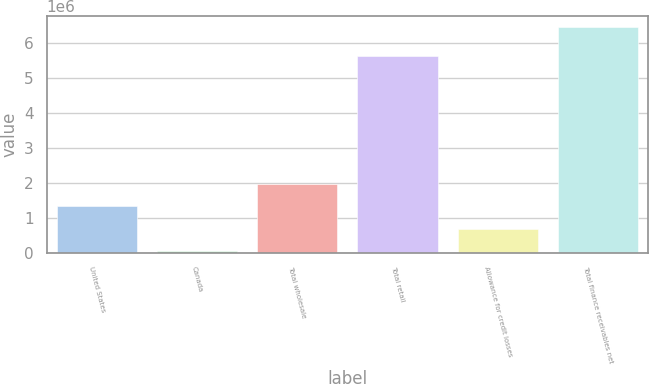Convert chart to OTSL. <chart><loc_0><loc_0><loc_500><loc_500><bar_chart><fcel>United States<fcel>Canada<fcel>Total wholesale<fcel>Total retail<fcel>Allowance for credit losses<fcel>Total finance receivables net<nl><fcel>1.32573e+06<fcel>48941<fcel>1.96412e+06<fcel>5.60792e+06<fcel>687335<fcel>6.43288e+06<nl></chart> 